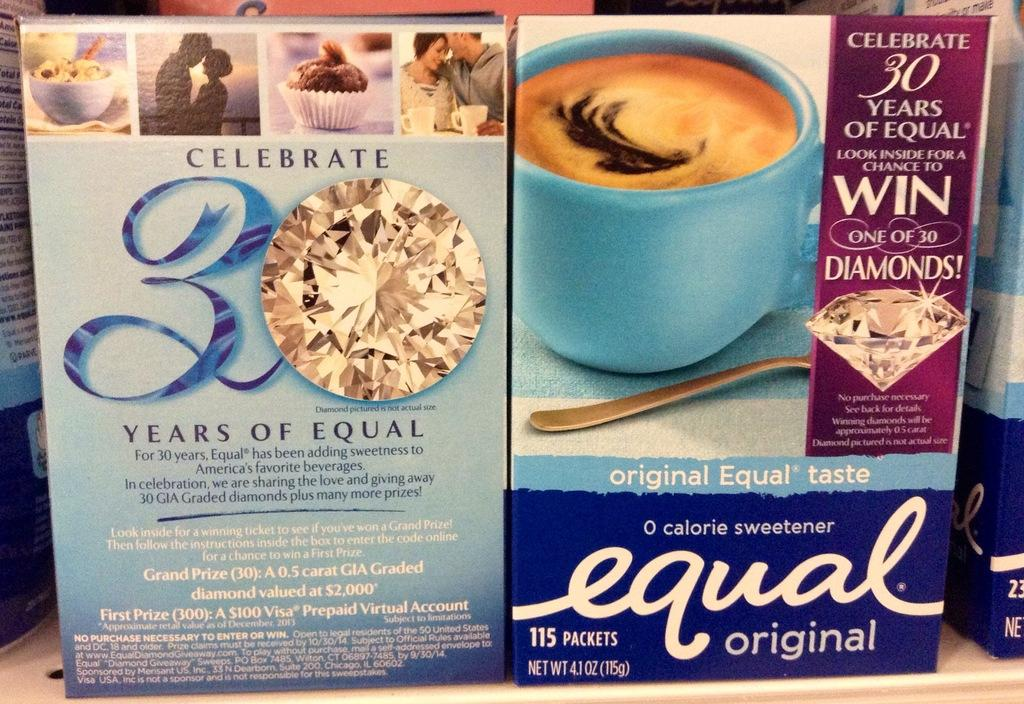Provide a one-sentence caption for the provided image. A 0 calorie sweetener by the brad Equal in original. 